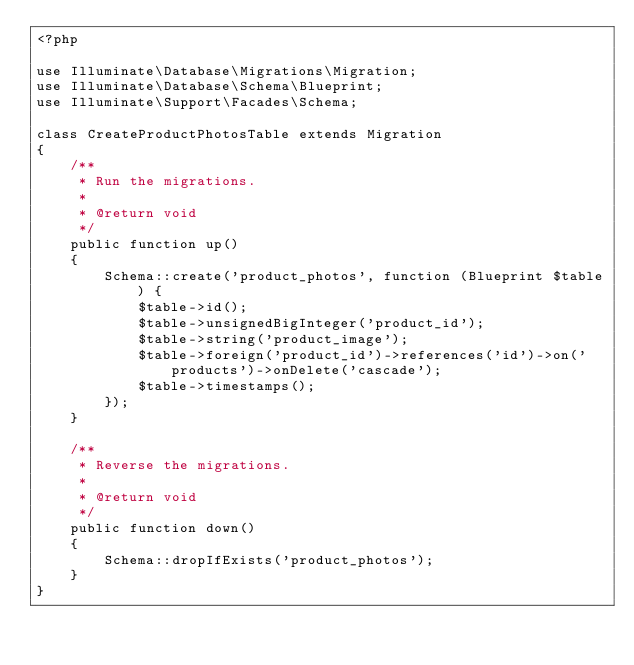<code> <loc_0><loc_0><loc_500><loc_500><_PHP_><?php

use Illuminate\Database\Migrations\Migration;
use Illuminate\Database\Schema\Blueprint;
use Illuminate\Support\Facades\Schema;

class CreateProductPhotosTable extends Migration
{
    /**
     * Run the migrations.
     *
     * @return void
     */
    public function up()
    {
        Schema::create('product_photos', function (Blueprint $table) {
            $table->id();
            $table->unsignedBigInteger('product_id');
            $table->string('product_image');
            $table->foreign('product_id')->references('id')->on('products')->onDelete('cascade');
            $table->timestamps();
        });
    }

    /**
     * Reverse the migrations.
     *
     * @return void
     */
    public function down()
    {
        Schema::dropIfExists('product_photos');
    }
}
</code> 